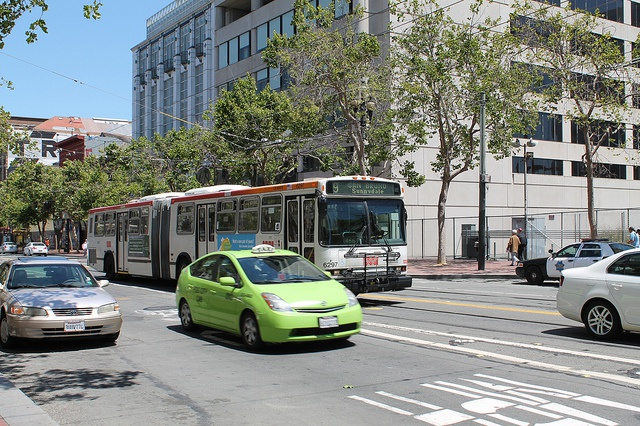Describe the objects in this image and their specific colors. I can see bus in lightblue, black, gray, darkgray, and lightgray tones, car in lightblue, black, darkgreen, lightgreen, and gray tones, car in lightblue, lightgray, gray, black, and darkgray tones, car in lightblue, darkgray, black, lightgray, and gray tones, and car in lightblue, black, darkgray, and gray tones in this image. 